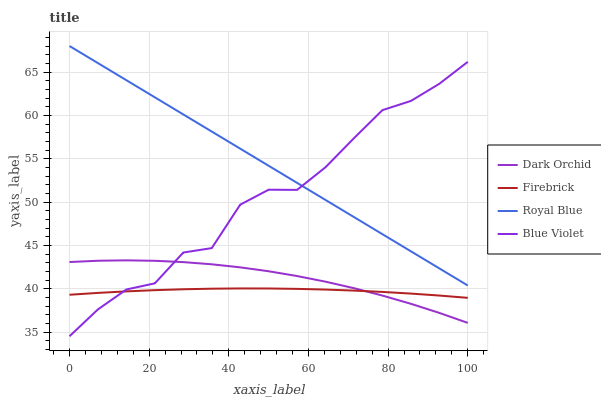Does Firebrick have the minimum area under the curve?
Answer yes or no. Yes. Does Blue Violet have the minimum area under the curve?
Answer yes or no. No. Does Blue Violet have the maximum area under the curve?
Answer yes or no. No. Is Firebrick the smoothest?
Answer yes or no. No. Is Firebrick the roughest?
Answer yes or no. No. Does Firebrick have the lowest value?
Answer yes or no. No. Does Blue Violet have the highest value?
Answer yes or no. No. Is Dark Orchid less than Royal Blue?
Answer yes or no. Yes. Is Royal Blue greater than Firebrick?
Answer yes or no. Yes. Does Dark Orchid intersect Royal Blue?
Answer yes or no. No. 